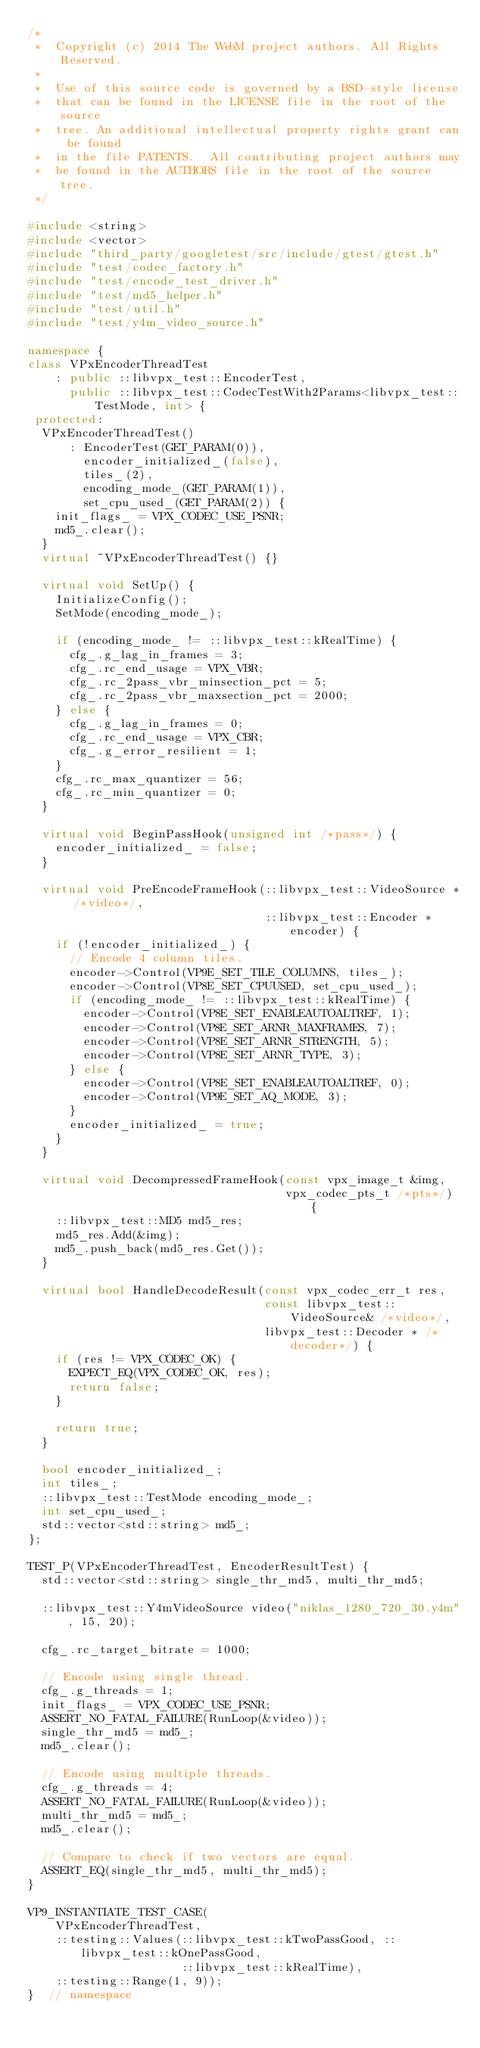Convert code to text. <code><loc_0><loc_0><loc_500><loc_500><_C++_>/*
 *  Copyright (c) 2014 The WebM project authors. All Rights Reserved.
 *
 *  Use of this source code is governed by a BSD-style license
 *  that can be found in the LICENSE file in the root of the source
 *  tree. An additional intellectual property rights grant can be found
 *  in the file PATENTS.  All contributing project authors may
 *  be found in the AUTHORS file in the root of the source tree.
 */

#include <string>
#include <vector>
#include "third_party/googletest/src/include/gtest/gtest.h"
#include "test/codec_factory.h"
#include "test/encode_test_driver.h"
#include "test/md5_helper.h"
#include "test/util.h"
#include "test/y4m_video_source.h"

namespace {
class VPxEncoderThreadTest
    : public ::libvpx_test::EncoderTest,
      public ::libvpx_test::CodecTestWith2Params<libvpx_test::TestMode, int> {
 protected:
  VPxEncoderThreadTest()
      : EncoderTest(GET_PARAM(0)),
        encoder_initialized_(false),
        tiles_(2),
        encoding_mode_(GET_PARAM(1)),
        set_cpu_used_(GET_PARAM(2)) {
    init_flags_ = VPX_CODEC_USE_PSNR;
    md5_.clear();
  }
  virtual ~VPxEncoderThreadTest() {}

  virtual void SetUp() {
    InitializeConfig();
    SetMode(encoding_mode_);

    if (encoding_mode_ != ::libvpx_test::kRealTime) {
      cfg_.g_lag_in_frames = 3;
      cfg_.rc_end_usage = VPX_VBR;
      cfg_.rc_2pass_vbr_minsection_pct = 5;
      cfg_.rc_2pass_vbr_maxsection_pct = 2000;
    } else {
      cfg_.g_lag_in_frames = 0;
      cfg_.rc_end_usage = VPX_CBR;
      cfg_.g_error_resilient = 1;
    }
    cfg_.rc_max_quantizer = 56;
    cfg_.rc_min_quantizer = 0;
  }

  virtual void BeginPassHook(unsigned int /*pass*/) {
    encoder_initialized_ = false;
  }

  virtual void PreEncodeFrameHook(::libvpx_test::VideoSource * /*video*/,
                                  ::libvpx_test::Encoder *encoder) {
    if (!encoder_initialized_) {
      // Encode 4 column tiles.
      encoder->Control(VP9E_SET_TILE_COLUMNS, tiles_);
      encoder->Control(VP8E_SET_CPUUSED, set_cpu_used_);
      if (encoding_mode_ != ::libvpx_test::kRealTime) {
        encoder->Control(VP8E_SET_ENABLEAUTOALTREF, 1);
        encoder->Control(VP8E_SET_ARNR_MAXFRAMES, 7);
        encoder->Control(VP8E_SET_ARNR_STRENGTH, 5);
        encoder->Control(VP8E_SET_ARNR_TYPE, 3);
      } else {
        encoder->Control(VP8E_SET_ENABLEAUTOALTREF, 0);
        encoder->Control(VP9E_SET_AQ_MODE, 3);
      }
      encoder_initialized_ = true;
    }
  }

  virtual void DecompressedFrameHook(const vpx_image_t &img,
                                     vpx_codec_pts_t /*pts*/) {
    ::libvpx_test::MD5 md5_res;
    md5_res.Add(&img);
    md5_.push_back(md5_res.Get());
  }

  virtual bool HandleDecodeResult(const vpx_codec_err_t res,
                                  const libvpx_test::VideoSource& /*video*/,
                                  libvpx_test::Decoder * /*decoder*/) {
    if (res != VPX_CODEC_OK) {
      EXPECT_EQ(VPX_CODEC_OK, res);
      return false;
    }

    return true;
  }

  bool encoder_initialized_;
  int tiles_;
  ::libvpx_test::TestMode encoding_mode_;
  int set_cpu_used_;
  std::vector<std::string> md5_;
};

TEST_P(VPxEncoderThreadTest, EncoderResultTest) {
  std::vector<std::string> single_thr_md5, multi_thr_md5;

  ::libvpx_test::Y4mVideoSource video("niklas_1280_720_30.y4m", 15, 20);

  cfg_.rc_target_bitrate = 1000;

  // Encode using single thread.
  cfg_.g_threads = 1;
  init_flags_ = VPX_CODEC_USE_PSNR;
  ASSERT_NO_FATAL_FAILURE(RunLoop(&video));
  single_thr_md5 = md5_;
  md5_.clear();

  // Encode using multiple threads.
  cfg_.g_threads = 4;
  ASSERT_NO_FATAL_FAILURE(RunLoop(&video));
  multi_thr_md5 = md5_;
  md5_.clear();

  // Compare to check if two vectors are equal.
  ASSERT_EQ(single_thr_md5, multi_thr_md5);
}

VP9_INSTANTIATE_TEST_CASE(
    VPxEncoderThreadTest,
    ::testing::Values(::libvpx_test::kTwoPassGood, ::libvpx_test::kOnePassGood,
                      ::libvpx_test::kRealTime),
    ::testing::Range(1, 9));
}  // namespace
</code> 